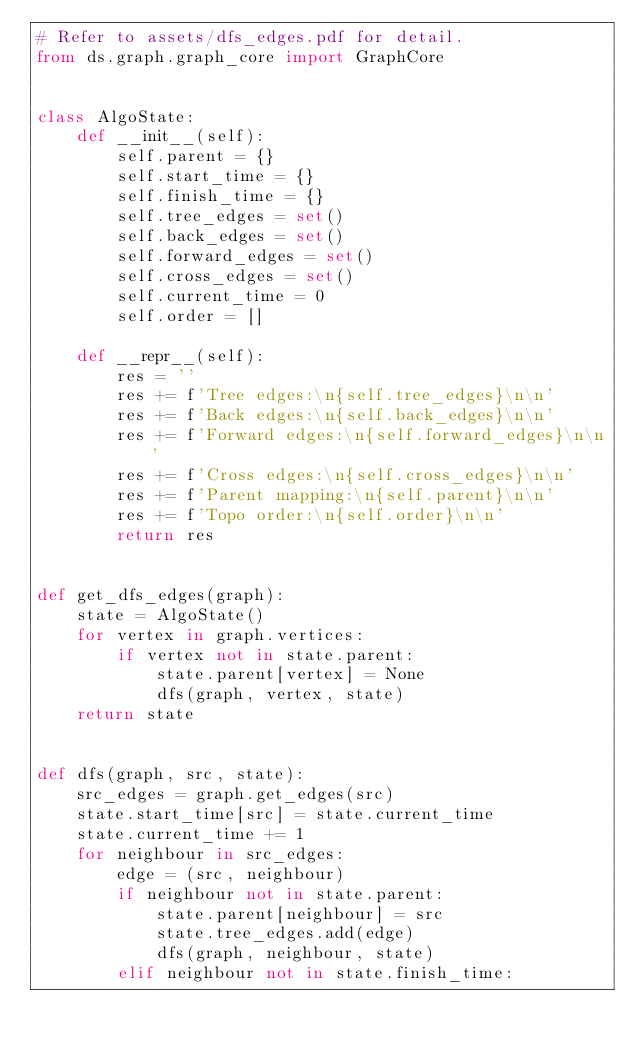<code> <loc_0><loc_0><loc_500><loc_500><_Python_># Refer to assets/dfs_edges.pdf for detail.
from ds.graph.graph_core import GraphCore


class AlgoState:
    def __init__(self):
        self.parent = {}
        self.start_time = {}
        self.finish_time = {}
        self.tree_edges = set()
        self.back_edges = set()
        self.forward_edges = set()
        self.cross_edges = set()
        self.current_time = 0
        self.order = []

    def __repr__(self):
        res = ''
        res += f'Tree edges:\n{self.tree_edges}\n\n'
        res += f'Back edges:\n{self.back_edges}\n\n'
        res += f'Forward edges:\n{self.forward_edges}\n\n'
        res += f'Cross edges:\n{self.cross_edges}\n\n'
        res += f'Parent mapping:\n{self.parent}\n\n'
        res += f'Topo order:\n{self.order}\n\n'
        return res


def get_dfs_edges(graph):
    state = AlgoState()
    for vertex in graph.vertices:
        if vertex not in state.parent:
            state.parent[vertex] = None
            dfs(graph, vertex, state)
    return state


def dfs(graph, src, state):
    src_edges = graph.get_edges(src)
    state.start_time[src] = state.current_time
    state.current_time += 1
    for neighbour in src_edges:
        edge = (src, neighbour)
        if neighbour not in state.parent:
            state.parent[neighbour] = src
            state.tree_edges.add(edge)
            dfs(graph, neighbour, state)
        elif neighbour not in state.finish_time:</code> 